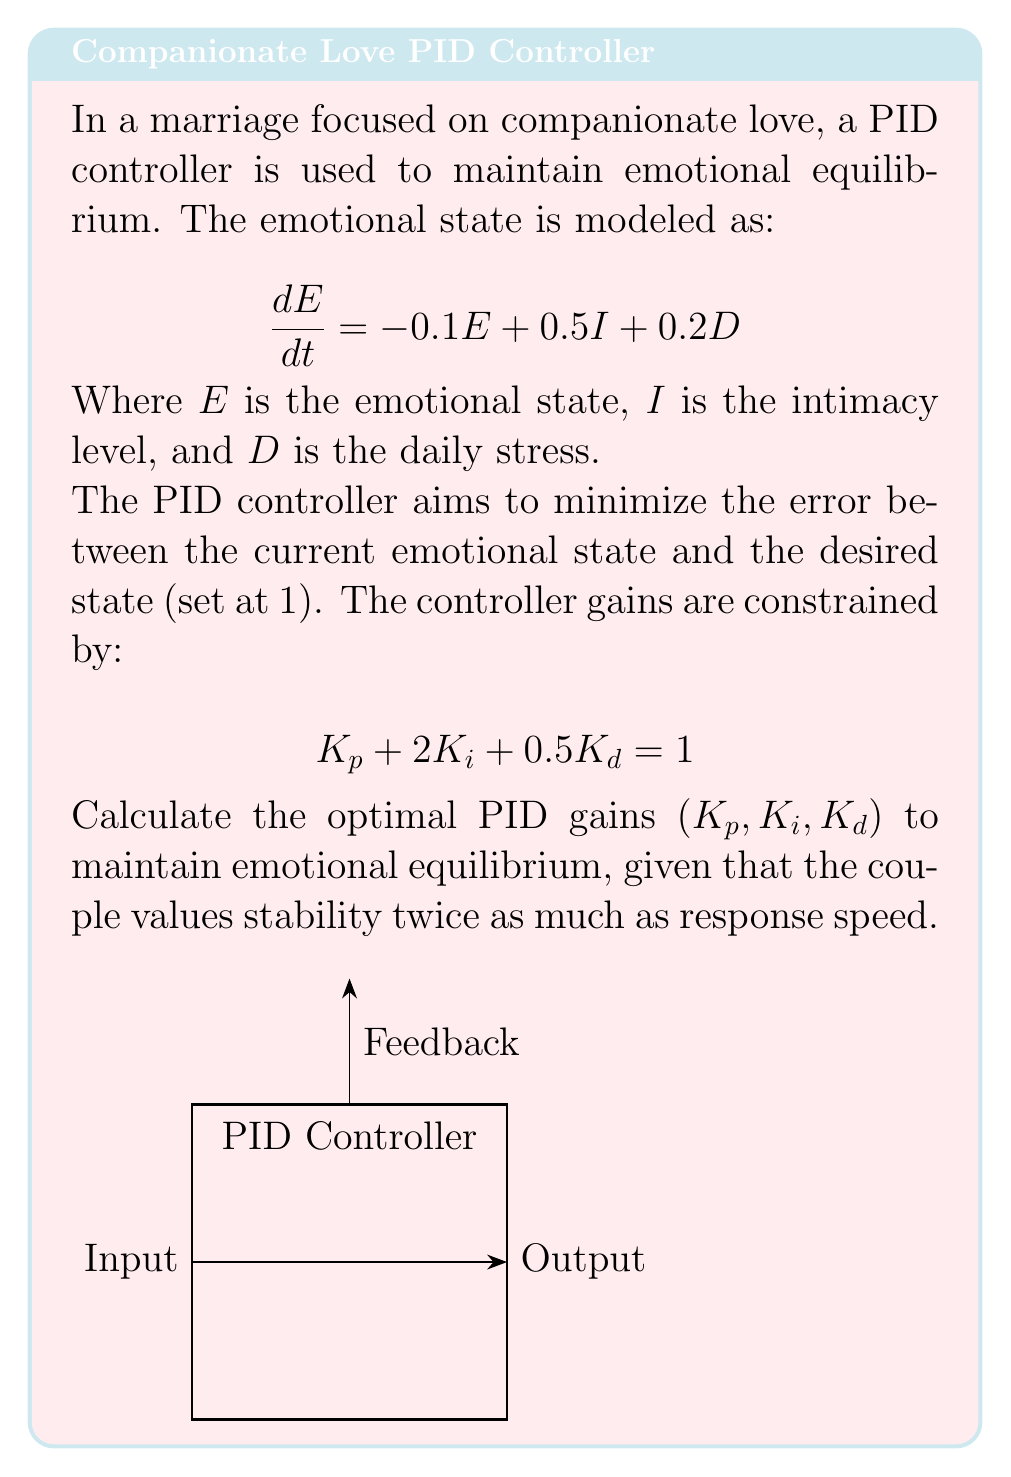Give your solution to this math problem. To solve this problem, we'll follow these steps:

1) The general form of a PID controller is:

   $$u(t) = K_p e(t) + K_i \int e(t) dt + K_d \frac{de(t)}{dt}$$

2) Given the constraint:

   $$K_p + 2K_i + 0.5K_d = 1$$

3) We need to balance stability and response speed. Stability is primarily affected by $K_p$ and $K_d$, while response speed is mainly influenced by $K_i$. Since stability is valued twice as much as response speed, we can set up a ratio:

   $$\frac{K_p + K_d}{K_i} = 2$$

4) Combining this with the constraint equation:

   $$K_p + K_d = 2K_i$$
   $$K_p + 2K_i + 0.5K_d = 1$$

5) Substituting the first equation into the second:

   $$(2K_i - K_d) + 2K_i + 0.5K_d = 1$$
   $$4K_i - 0.5K_d = 1$$

6) From step 4, we can express $K_p$ in terms of $K_i$ and $K_d$:

   $$K_p = 2K_i - K_d$$

7) Now we have a system of three equations with three unknowns. Solving this system:

   $$K_i = 0.2$$
   $$K_d = 0.4$$
   $$K_p = 0.2$$

8) We can verify that these values satisfy both the constraint and the stability-speed ratio:

   $$0.2 + 2(0.2) + 0.5(0.4) = 1$$
   $$\frac{0.2 + 0.4}{0.2} = 2$$
Answer: $K_p = 0.2$, $K_i = 0.2$, $K_d = 0.4$ 